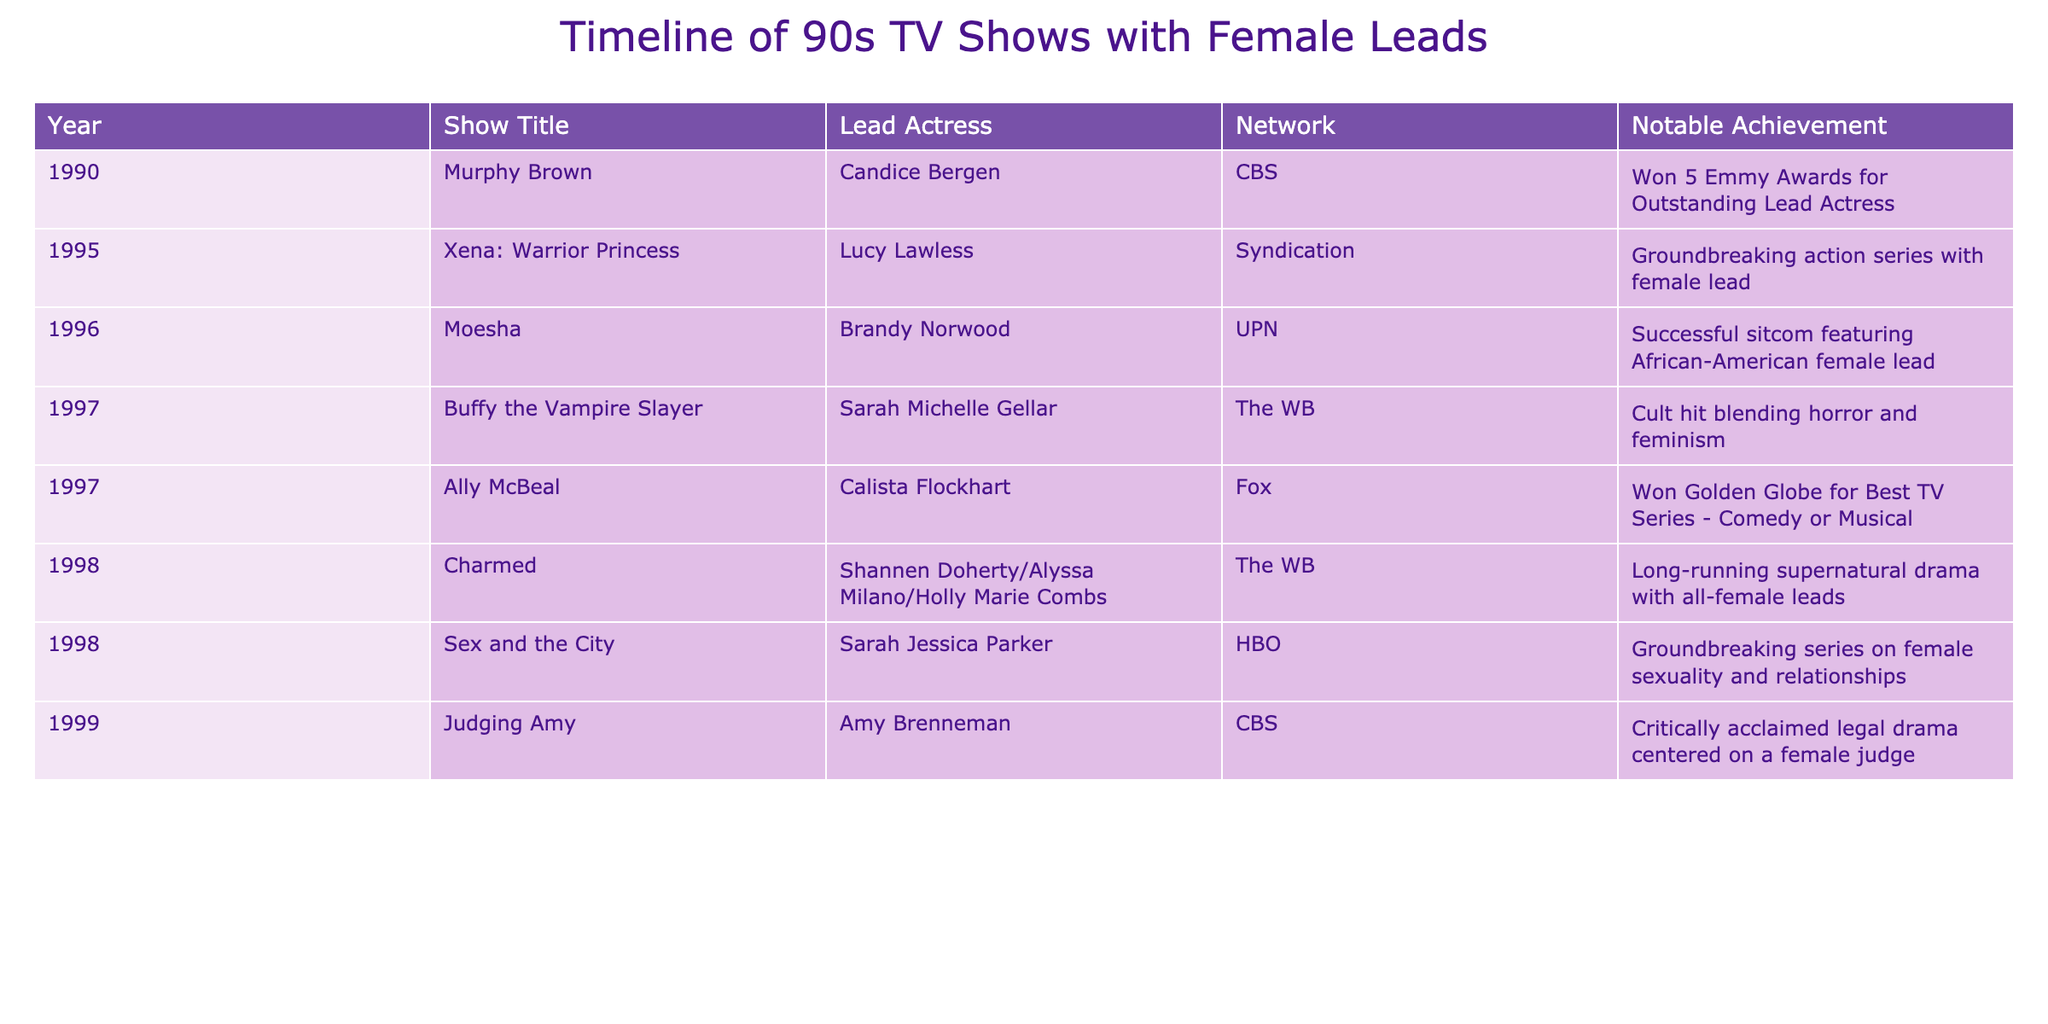What year did "Murphy Brown" premiere? The table indicates that "Murphy Brown" premiered in 1990, as shown in the "Year" column next to the "Show Title."
Answer: 1990 Which show won the most Emmy Awards for its lead actress? According to the table, "Murphy Brown" won 5 Emmy Awards for Outstanding Lead Actress, as stated in the "Notable Achievement" column.
Answer: Murphy Brown How many shows aired on CBS? From the table, I can see two shows listed under CBS: "Murphy Brown" (1990) and "Judging Amy" (1999). Thus, the count is 2.
Answer: 2 Did any shows that aired on HBO focus on female relationships? The table shows that "Sex and the City" aired on HBO and it is noted as a groundbreaking series on female sexuality and relationships. Therefore, the answer is yes.
Answer: Yes Which show features a lead character who is a judge? "Judging Amy" is noted in the table as a legal drama centered on a female judge, identified under the "Show Title" and "Notable Achievement" columns.
Answer: Judging Amy What percentage of the shows listed aired on The WB network? There are 3 shows from The WB: "Buffy the Vampire Slayer," "Charmed," and "Sex and the City," out of a total of 9 shows. To calculate the percentage: (3/9) * 100 = 33.33.
Answer: 33.33% Which actress led "Xena: Warrior Princess"? The table clearly states that Lucy Lawless was the lead actress for "Xena: Warrior Princess" in 1995.
Answer: Lucy Lawless What notable achievement did "Ally McBeal" receive? The table indicates that "Ally McBeal" won a Golden Globe for Best TV Series - Comedy or Musical, which is mentioned in the "Notable Achievement" column.
Answer: Won Golden Globe for Best TV Series How many shows in the table had a supernatural theme? The table lists "Charmed" (1998) as a long-running supernatural drama. Upon review, this is the only show that fits this theme, leading to a total of 1 show.
Answer: 1 Which two shows aired in 1997? According to the table, "Buffy the Vampire Slayer" and "Ally McBeal" both premiered in 1997, as seen under the "Year" column.
Answer: Buffy the Vampire Slayer, Ally McBeal 